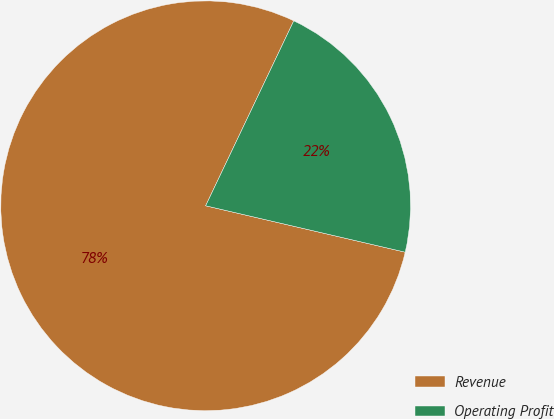Convert chart to OTSL. <chart><loc_0><loc_0><loc_500><loc_500><pie_chart><fcel>Revenue<fcel>Operating Profit<nl><fcel>78.44%<fcel>21.56%<nl></chart> 